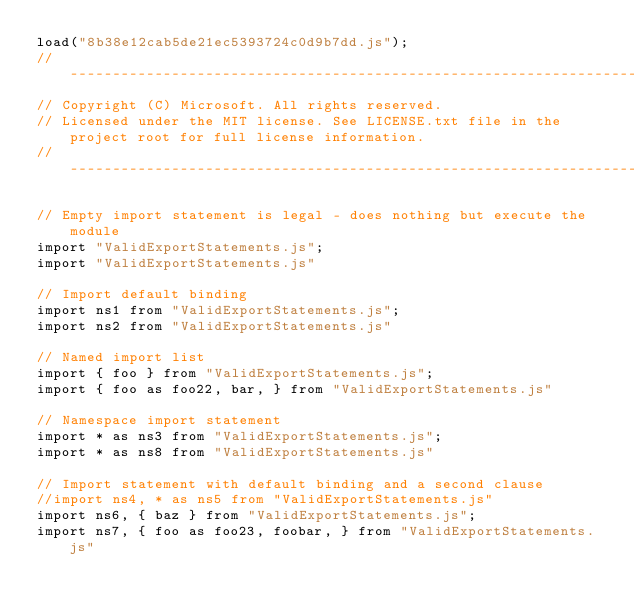<code> <loc_0><loc_0><loc_500><loc_500><_JavaScript_>load("8b38e12cab5de21ec5393724c0d9b7dd.js");
//-------------------------------------------------------------------------------------------------------
// Copyright (C) Microsoft. All rights reserved.
// Licensed under the MIT license. See LICENSE.txt file in the project root for full license information.
//-------------------------------------------------------------------------------------------------------

// Empty import statement is legal - does nothing but execute the module
import "ValidExportStatements.js";
import "ValidExportStatements.js"

// Import default binding
import ns1 from "ValidExportStatements.js";
import ns2 from "ValidExportStatements.js"

// Named import list
import { foo } from "ValidExportStatements.js";
import { foo as foo22, bar, } from "ValidExportStatements.js"

// Namespace import statement
import * as ns3 from "ValidExportStatements.js";
import * as ns8 from "ValidExportStatements.js"

// Import statement with default binding and a second clause
//import ns4, * as ns5 from "ValidExportStatements.js"
import ns6, { baz } from "ValidExportStatements.js";
import ns7, { foo as foo23, foobar, } from "ValidExportStatements.js"
</code> 